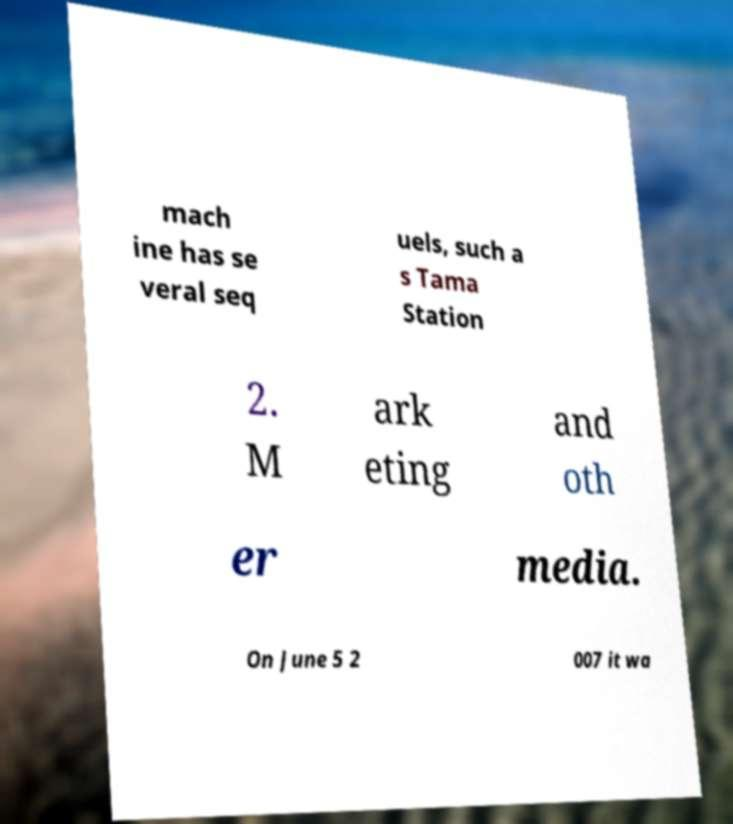What messages or text are displayed in this image? I need them in a readable, typed format. mach ine has se veral seq uels, such a s Tama Station 2. M ark eting and oth er media. On June 5 2 007 it wa 